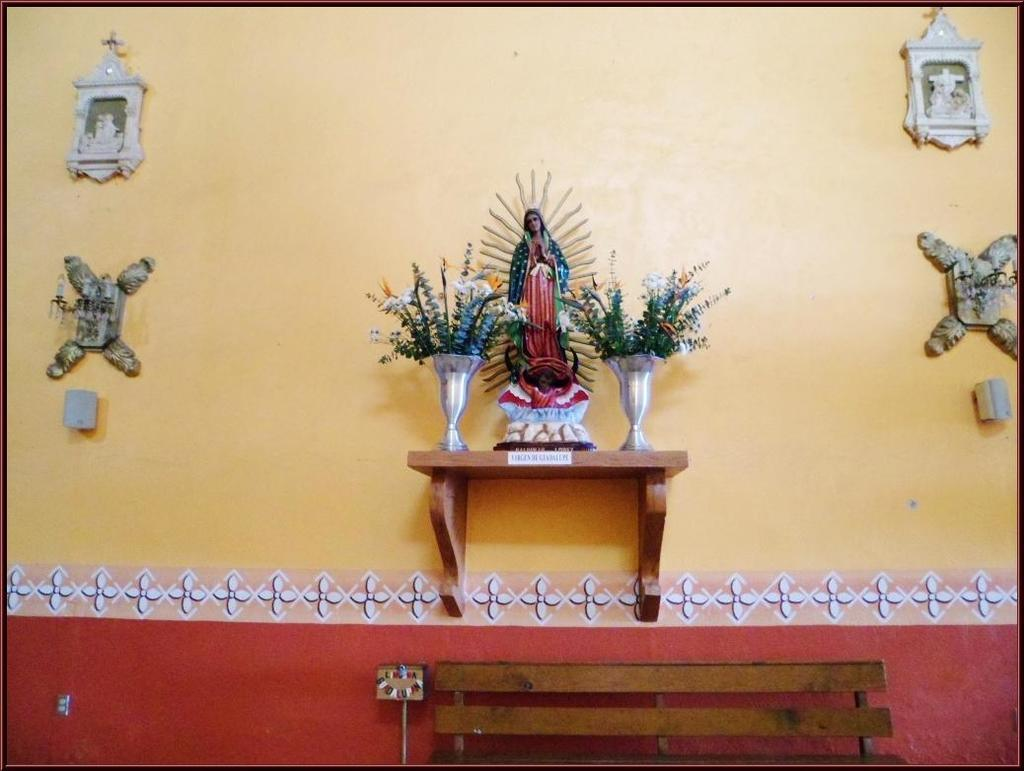What type of seating is visible in the image? There is a bench in the image. What is located behind the bench? There is a wall behind the bench. What decorative elements are present on the wall? There is a sculpture and flower pots on the wall. How many cars are parked near the bench in the image? There is no mention of cars in the image, so it is not possible to determine how many are parked near the bench. 